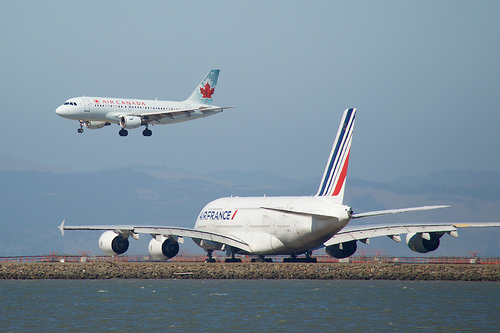<image>
Can you confirm if the flying plane is on the runway plane? No. The flying plane is not positioned on the runway plane. They may be near each other, but the flying plane is not supported by or resting on top of the runway plane. Is the airplane above the engine? Yes. The airplane is positioned above the engine in the vertical space, higher up in the scene. 